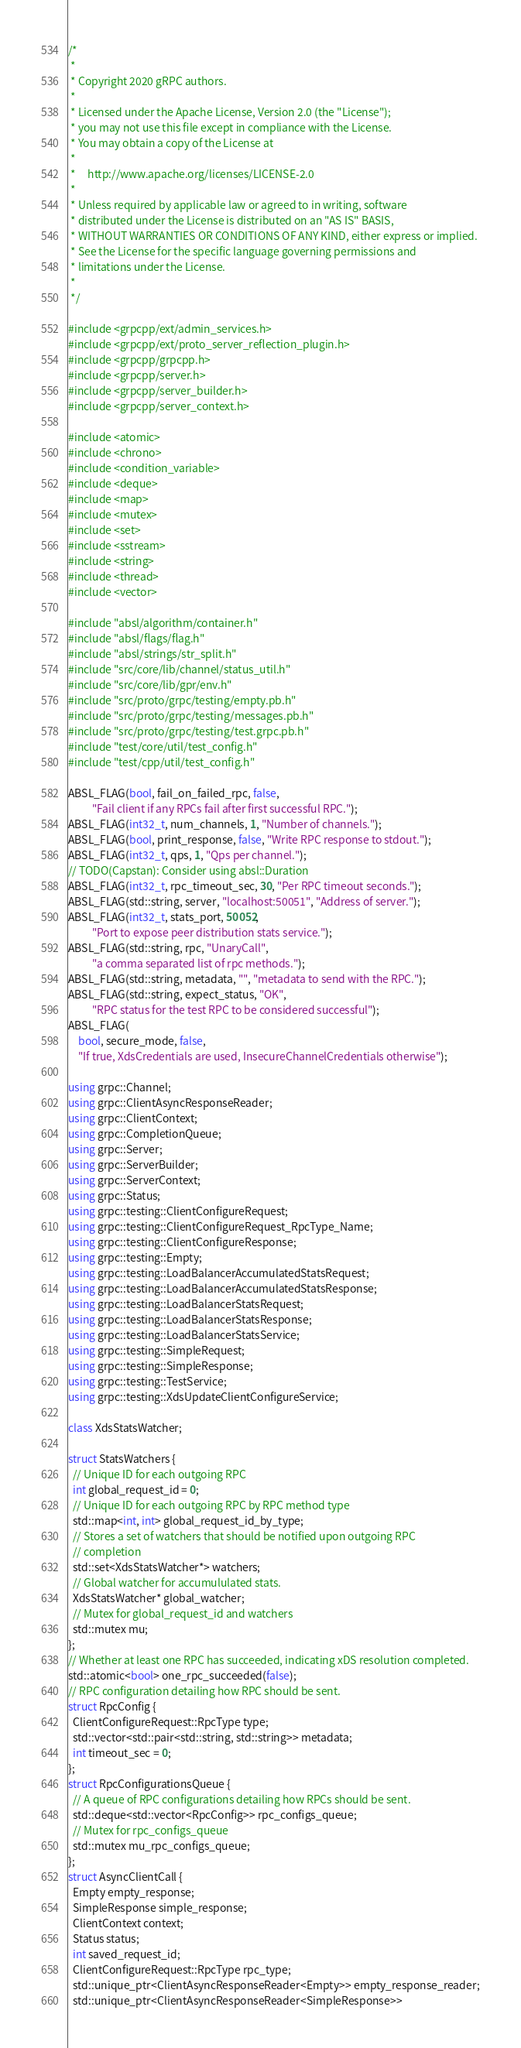<code> <loc_0><loc_0><loc_500><loc_500><_C++_>/*
 *
 * Copyright 2020 gRPC authors.
 *
 * Licensed under the Apache License, Version 2.0 (the "License");
 * you may not use this file except in compliance with the License.
 * You may obtain a copy of the License at
 *
 *     http://www.apache.org/licenses/LICENSE-2.0
 *
 * Unless required by applicable law or agreed to in writing, software
 * distributed under the License is distributed on an "AS IS" BASIS,
 * WITHOUT WARRANTIES OR CONDITIONS OF ANY KIND, either express or implied.
 * See the License for the specific language governing permissions and
 * limitations under the License.
 *
 */

#include <grpcpp/ext/admin_services.h>
#include <grpcpp/ext/proto_server_reflection_plugin.h>
#include <grpcpp/grpcpp.h>
#include <grpcpp/server.h>
#include <grpcpp/server_builder.h>
#include <grpcpp/server_context.h>

#include <atomic>
#include <chrono>
#include <condition_variable>
#include <deque>
#include <map>
#include <mutex>
#include <set>
#include <sstream>
#include <string>
#include <thread>
#include <vector>

#include "absl/algorithm/container.h"
#include "absl/flags/flag.h"
#include "absl/strings/str_split.h"
#include "src/core/lib/channel/status_util.h"
#include "src/core/lib/gpr/env.h"
#include "src/proto/grpc/testing/empty.pb.h"
#include "src/proto/grpc/testing/messages.pb.h"
#include "src/proto/grpc/testing/test.grpc.pb.h"
#include "test/core/util/test_config.h"
#include "test/cpp/util/test_config.h"

ABSL_FLAG(bool, fail_on_failed_rpc, false,
          "Fail client if any RPCs fail after first successful RPC.");
ABSL_FLAG(int32_t, num_channels, 1, "Number of channels.");
ABSL_FLAG(bool, print_response, false, "Write RPC response to stdout.");
ABSL_FLAG(int32_t, qps, 1, "Qps per channel.");
// TODO(Capstan): Consider using absl::Duration
ABSL_FLAG(int32_t, rpc_timeout_sec, 30, "Per RPC timeout seconds.");
ABSL_FLAG(std::string, server, "localhost:50051", "Address of server.");
ABSL_FLAG(int32_t, stats_port, 50052,
          "Port to expose peer distribution stats service.");
ABSL_FLAG(std::string, rpc, "UnaryCall",
          "a comma separated list of rpc methods.");
ABSL_FLAG(std::string, metadata, "", "metadata to send with the RPC.");
ABSL_FLAG(std::string, expect_status, "OK",
          "RPC status for the test RPC to be considered successful");
ABSL_FLAG(
    bool, secure_mode, false,
    "If true, XdsCredentials are used, InsecureChannelCredentials otherwise");

using grpc::Channel;
using grpc::ClientAsyncResponseReader;
using grpc::ClientContext;
using grpc::CompletionQueue;
using grpc::Server;
using grpc::ServerBuilder;
using grpc::ServerContext;
using grpc::Status;
using grpc::testing::ClientConfigureRequest;
using grpc::testing::ClientConfigureRequest_RpcType_Name;
using grpc::testing::ClientConfigureResponse;
using grpc::testing::Empty;
using grpc::testing::LoadBalancerAccumulatedStatsRequest;
using grpc::testing::LoadBalancerAccumulatedStatsResponse;
using grpc::testing::LoadBalancerStatsRequest;
using grpc::testing::LoadBalancerStatsResponse;
using grpc::testing::LoadBalancerStatsService;
using grpc::testing::SimpleRequest;
using grpc::testing::SimpleResponse;
using grpc::testing::TestService;
using grpc::testing::XdsUpdateClientConfigureService;

class XdsStatsWatcher;

struct StatsWatchers {
  // Unique ID for each outgoing RPC
  int global_request_id = 0;
  // Unique ID for each outgoing RPC by RPC method type
  std::map<int, int> global_request_id_by_type;
  // Stores a set of watchers that should be notified upon outgoing RPC
  // completion
  std::set<XdsStatsWatcher*> watchers;
  // Global watcher for accumululated stats.
  XdsStatsWatcher* global_watcher;
  // Mutex for global_request_id and watchers
  std::mutex mu;
};
// Whether at least one RPC has succeeded, indicating xDS resolution completed.
std::atomic<bool> one_rpc_succeeded(false);
// RPC configuration detailing how RPC should be sent.
struct RpcConfig {
  ClientConfigureRequest::RpcType type;
  std::vector<std::pair<std::string, std::string>> metadata;
  int timeout_sec = 0;
};
struct RpcConfigurationsQueue {
  // A queue of RPC configurations detailing how RPCs should be sent.
  std::deque<std::vector<RpcConfig>> rpc_configs_queue;
  // Mutex for rpc_configs_queue
  std::mutex mu_rpc_configs_queue;
};
struct AsyncClientCall {
  Empty empty_response;
  SimpleResponse simple_response;
  ClientContext context;
  Status status;
  int saved_request_id;
  ClientConfigureRequest::RpcType rpc_type;
  std::unique_ptr<ClientAsyncResponseReader<Empty>> empty_response_reader;
  std::unique_ptr<ClientAsyncResponseReader<SimpleResponse>></code> 